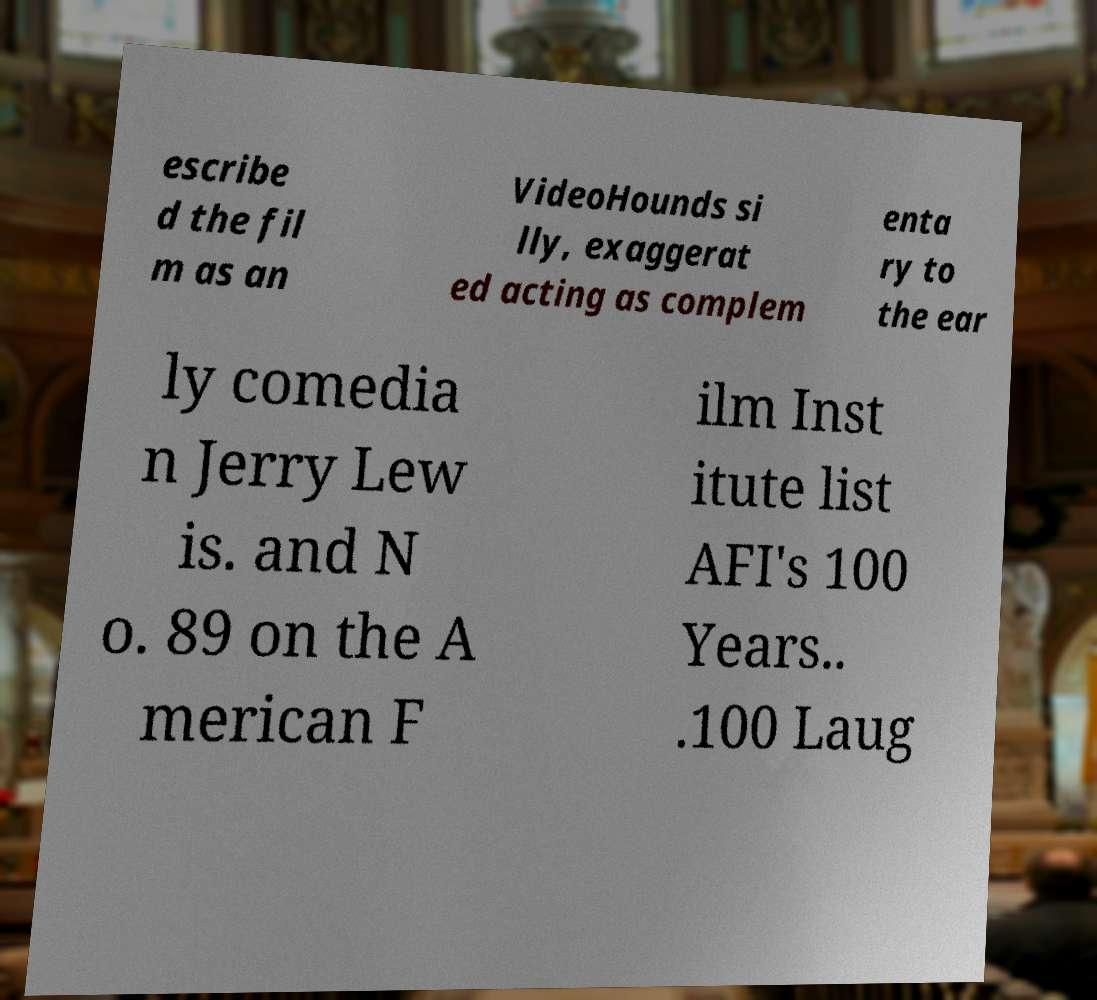Can you accurately transcribe the text from the provided image for me? escribe d the fil m as an VideoHounds si lly, exaggerat ed acting as complem enta ry to the ear ly comedia n Jerry Lew is. and N o. 89 on the A merican F ilm Inst itute list AFI's 100 Years.. .100 Laug 